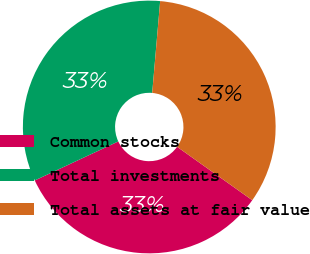Convert chart. <chart><loc_0><loc_0><loc_500><loc_500><pie_chart><fcel>Common stocks<fcel>Total investments<fcel>Total assets at fair value<nl><fcel>33.21%<fcel>33.33%<fcel>33.46%<nl></chart> 